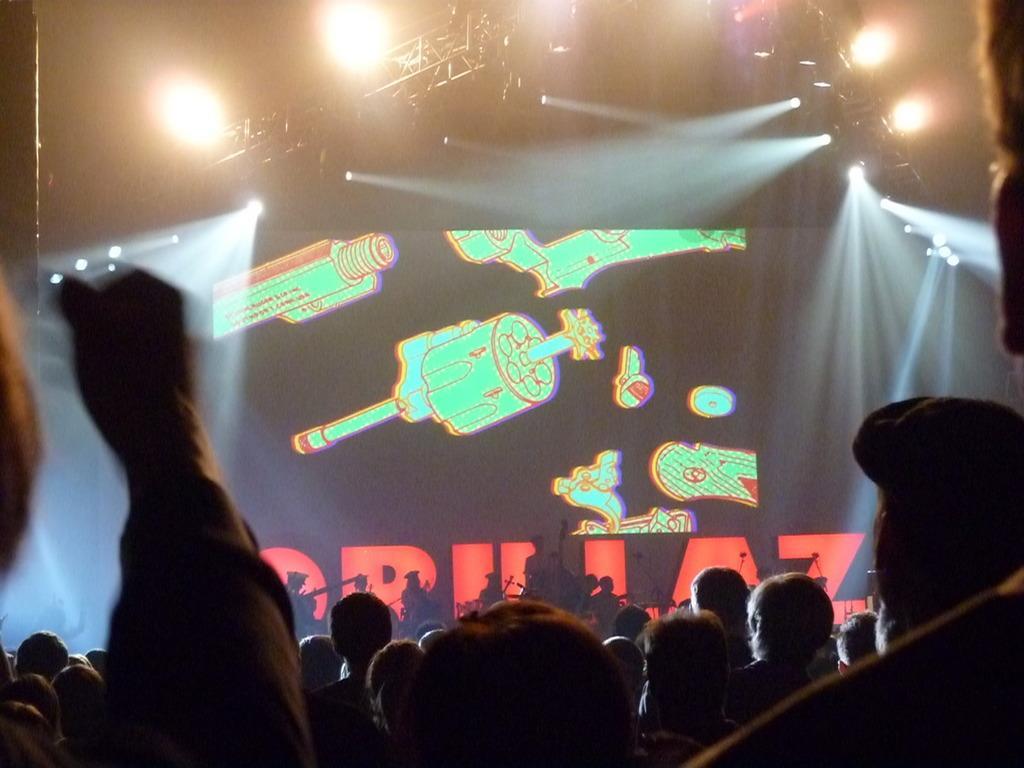How would you summarize this image in a sentence or two? In this image we can see a few people, some of them are playing musical instruments, behind them there is a poster with some text, and images on it, also we can see some lights, and poles. 